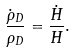Convert formula to latex. <formula><loc_0><loc_0><loc_500><loc_500>\frac { \dot { \rho } _ { D } } { \rho _ { D } } = \frac { \dot { H } } { H } .</formula> 